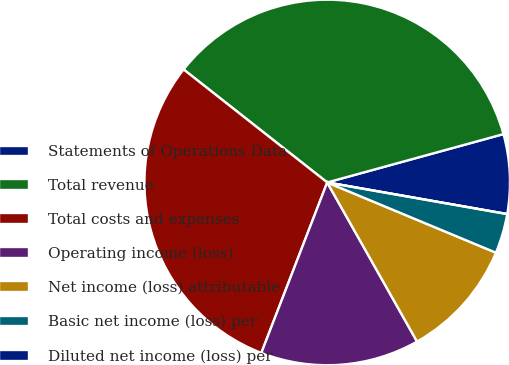Convert chart to OTSL. <chart><loc_0><loc_0><loc_500><loc_500><pie_chart><fcel>Statements of Operations Data<fcel>Total revenue<fcel>Total costs and expenses<fcel>Operating income (loss)<fcel>Net income (loss) attributable<fcel>Basic net income (loss) per<fcel>Diluted net income (loss) per<nl><fcel>7.03%<fcel>35.13%<fcel>29.74%<fcel>14.05%<fcel>10.54%<fcel>3.51%<fcel>0.0%<nl></chart> 